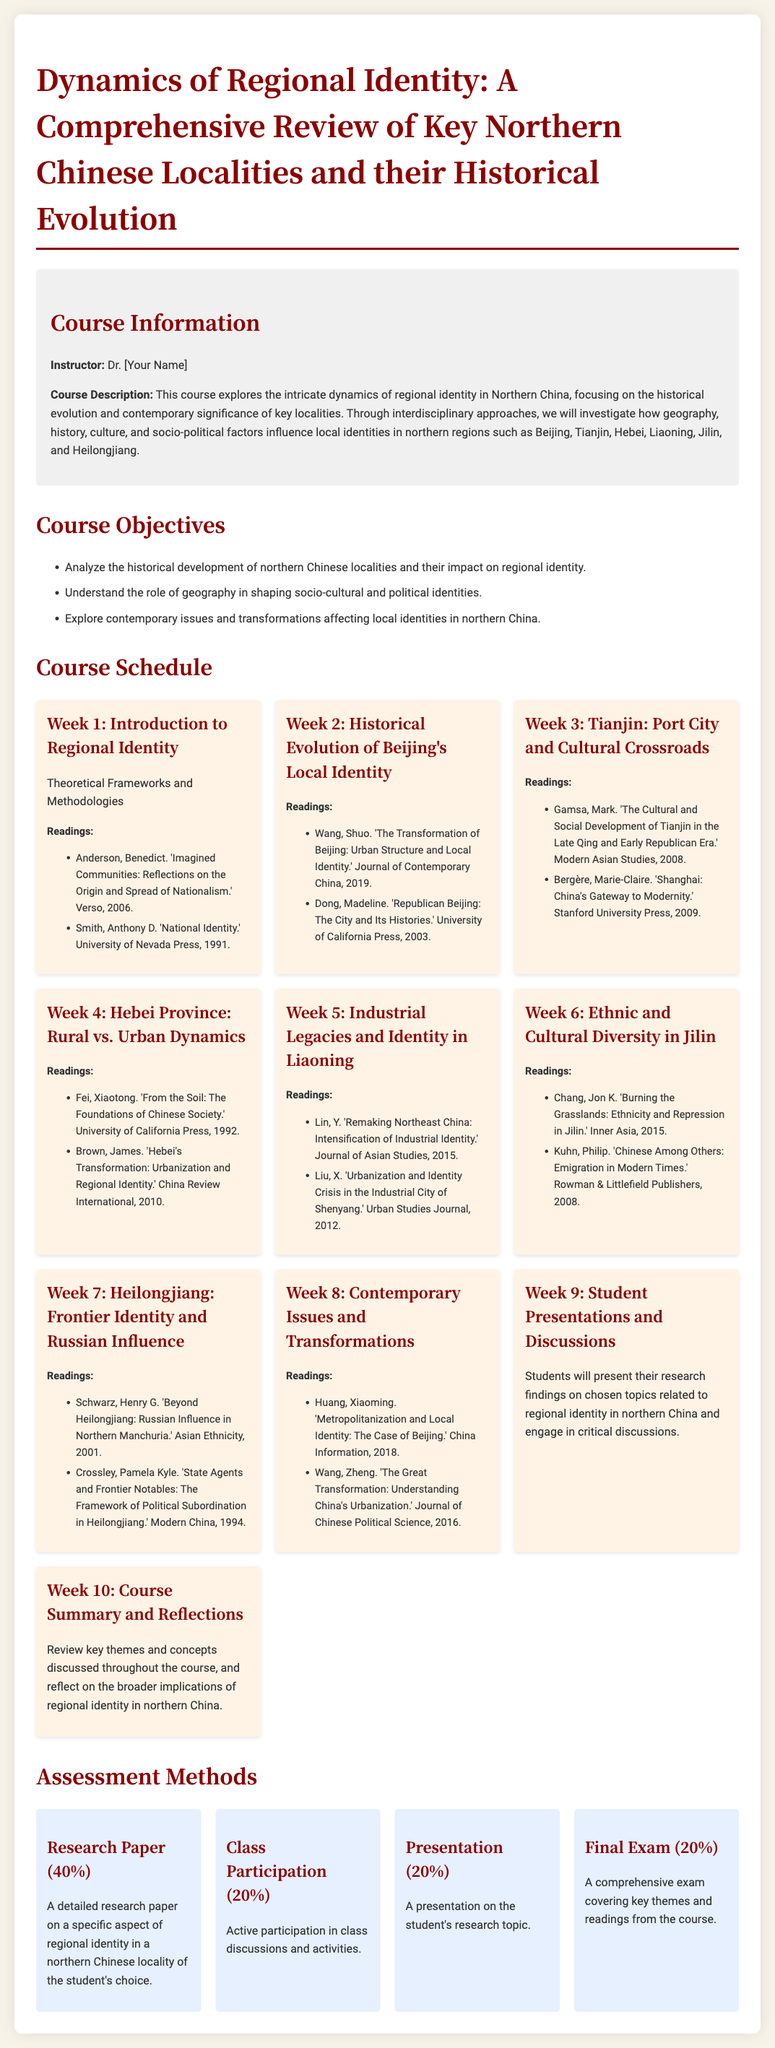What is the course title? The course title is found in the heading of the document, which provides the main topic of study.
Answer: Dynamics of Regional Identity: A Comprehensive Review of Key Northern Chinese Localities and their Historical Evolution Who is the instructor of the course? Instructor information is presented in the course information section of the document.
Answer: Dr. [Your Name] What is the percentage weight of the research paper in the assessment? The research paper's weight is explicitly listed under the assessment methods section.
Answer: 40% How many weeks are dedicated to the course schedule? The number of weeks is determined by counting the distinct weekly topics presented in the course schedule section.
Answer: 10 Which week covers the topic of ethnic and cultural diversity in Jilin? The specific week discussing Jilin is mentioned in the course schedule by title.
Answer: Week 6 What is the focus of Week 4 in the course? The focus of each week is provided in the course schedule, detailing the themes discussed.
Answer: Rural vs. Urban Dynamics What type of participation is graded at 20%? The type of participation and its grading percentage is specifically listed in the assessment methods section.
Answer: Class Participation Which reading is suggested for understanding Beijing's local identity? The readings related to each week's topic can be found under their respective sections in the schedule.
Answer: 'The Transformation of Beijing: Urban Structure and Local Identity.' 